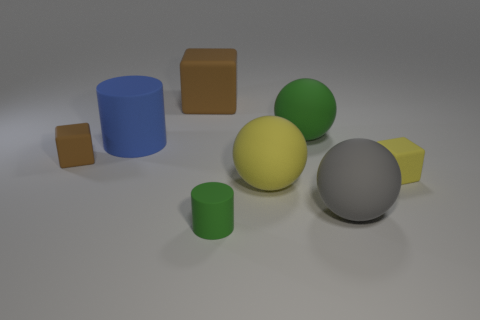There is a large matte block; how many large brown rubber objects are in front of it?
Make the answer very short. 0. Is there a brown matte cylinder of the same size as the yellow block?
Give a very brief answer. No. There is a matte thing that is behind the large green ball; is its shape the same as the big blue rubber thing?
Provide a succinct answer. No. The large matte cylinder has what color?
Keep it short and to the point. Blue. There is a object that is the same color as the large rubber cube; what shape is it?
Offer a terse response. Cube. Are any tiny red matte objects visible?
Your answer should be compact. No. What is the size of the other cylinder that is the same material as the green cylinder?
Keep it short and to the point. Large. What shape is the small object that is right of the green thing behind the tiny green matte cylinder in front of the tiny yellow block?
Your response must be concise. Cube. Are there the same number of yellow balls that are to the right of the green cylinder and green matte things?
Offer a terse response. No. There is another rubber cube that is the same color as the big rubber block; what size is it?
Give a very brief answer. Small. 